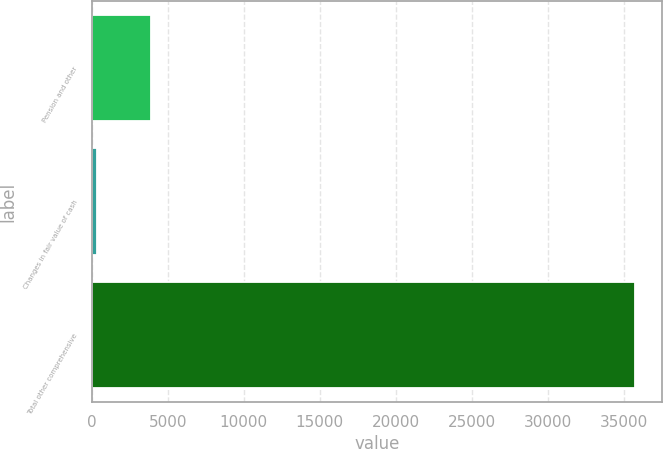Convert chart to OTSL. <chart><loc_0><loc_0><loc_500><loc_500><bar_chart><fcel>Pension and other<fcel>Changes in fair value of cash<fcel>Total other comprehensive<nl><fcel>3898.4<fcel>360<fcel>35744<nl></chart> 